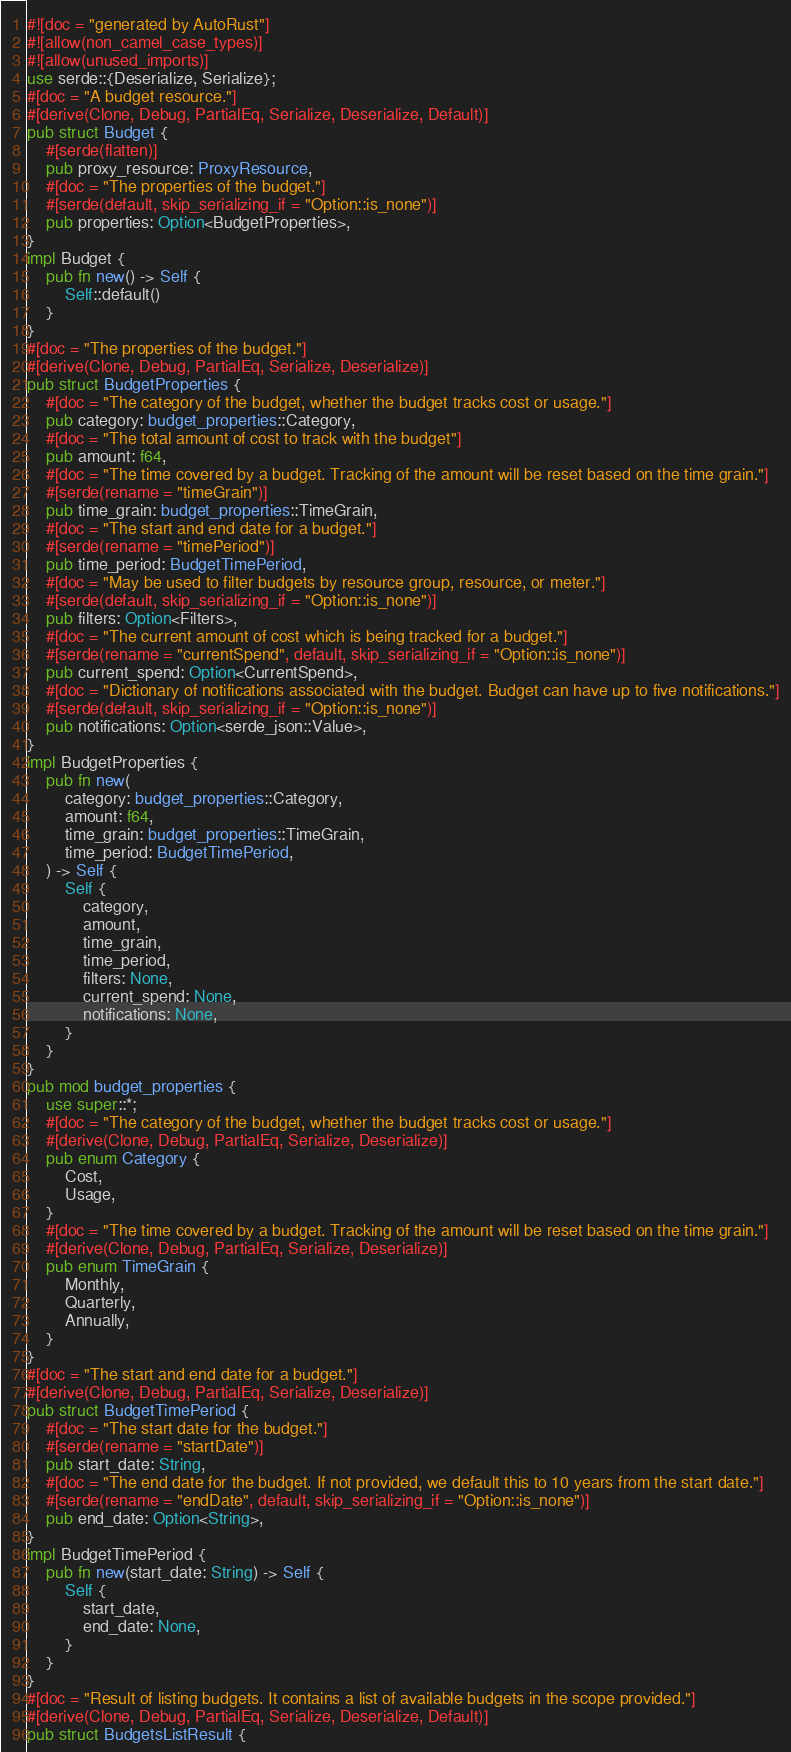Convert code to text. <code><loc_0><loc_0><loc_500><loc_500><_Rust_>#![doc = "generated by AutoRust"]
#![allow(non_camel_case_types)]
#![allow(unused_imports)]
use serde::{Deserialize, Serialize};
#[doc = "A budget resource."]
#[derive(Clone, Debug, PartialEq, Serialize, Deserialize, Default)]
pub struct Budget {
    #[serde(flatten)]
    pub proxy_resource: ProxyResource,
    #[doc = "The properties of the budget."]
    #[serde(default, skip_serializing_if = "Option::is_none")]
    pub properties: Option<BudgetProperties>,
}
impl Budget {
    pub fn new() -> Self {
        Self::default()
    }
}
#[doc = "The properties of the budget."]
#[derive(Clone, Debug, PartialEq, Serialize, Deserialize)]
pub struct BudgetProperties {
    #[doc = "The category of the budget, whether the budget tracks cost or usage."]
    pub category: budget_properties::Category,
    #[doc = "The total amount of cost to track with the budget"]
    pub amount: f64,
    #[doc = "The time covered by a budget. Tracking of the amount will be reset based on the time grain."]
    #[serde(rename = "timeGrain")]
    pub time_grain: budget_properties::TimeGrain,
    #[doc = "The start and end date for a budget."]
    #[serde(rename = "timePeriod")]
    pub time_period: BudgetTimePeriod,
    #[doc = "May be used to filter budgets by resource group, resource, or meter."]
    #[serde(default, skip_serializing_if = "Option::is_none")]
    pub filters: Option<Filters>,
    #[doc = "The current amount of cost which is being tracked for a budget."]
    #[serde(rename = "currentSpend", default, skip_serializing_if = "Option::is_none")]
    pub current_spend: Option<CurrentSpend>,
    #[doc = "Dictionary of notifications associated with the budget. Budget can have up to five notifications."]
    #[serde(default, skip_serializing_if = "Option::is_none")]
    pub notifications: Option<serde_json::Value>,
}
impl BudgetProperties {
    pub fn new(
        category: budget_properties::Category,
        amount: f64,
        time_grain: budget_properties::TimeGrain,
        time_period: BudgetTimePeriod,
    ) -> Self {
        Self {
            category,
            amount,
            time_grain,
            time_period,
            filters: None,
            current_spend: None,
            notifications: None,
        }
    }
}
pub mod budget_properties {
    use super::*;
    #[doc = "The category of the budget, whether the budget tracks cost or usage."]
    #[derive(Clone, Debug, PartialEq, Serialize, Deserialize)]
    pub enum Category {
        Cost,
        Usage,
    }
    #[doc = "The time covered by a budget. Tracking of the amount will be reset based on the time grain."]
    #[derive(Clone, Debug, PartialEq, Serialize, Deserialize)]
    pub enum TimeGrain {
        Monthly,
        Quarterly,
        Annually,
    }
}
#[doc = "The start and end date for a budget."]
#[derive(Clone, Debug, PartialEq, Serialize, Deserialize)]
pub struct BudgetTimePeriod {
    #[doc = "The start date for the budget."]
    #[serde(rename = "startDate")]
    pub start_date: String,
    #[doc = "The end date for the budget. If not provided, we default this to 10 years from the start date."]
    #[serde(rename = "endDate", default, skip_serializing_if = "Option::is_none")]
    pub end_date: Option<String>,
}
impl BudgetTimePeriod {
    pub fn new(start_date: String) -> Self {
        Self {
            start_date,
            end_date: None,
        }
    }
}
#[doc = "Result of listing budgets. It contains a list of available budgets in the scope provided."]
#[derive(Clone, Debug, PartialEq, Serialize, Deserialize, Default)]
pub struct BudgetsListResult {</code> 